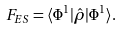Convert formula to latex. <formula><loc_0><loc_0><loc_500><loc_500>F _ { E S } = \langle \Phi ^ { 1 } | \hat { \rho } | \Phi ^ { 1 } \rangle .</formula> 